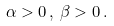<formula> <loc_0><loc_0><loc_500><loc_500>\alpha > 0 \, , \, \beta > 0 \, .</formula> 